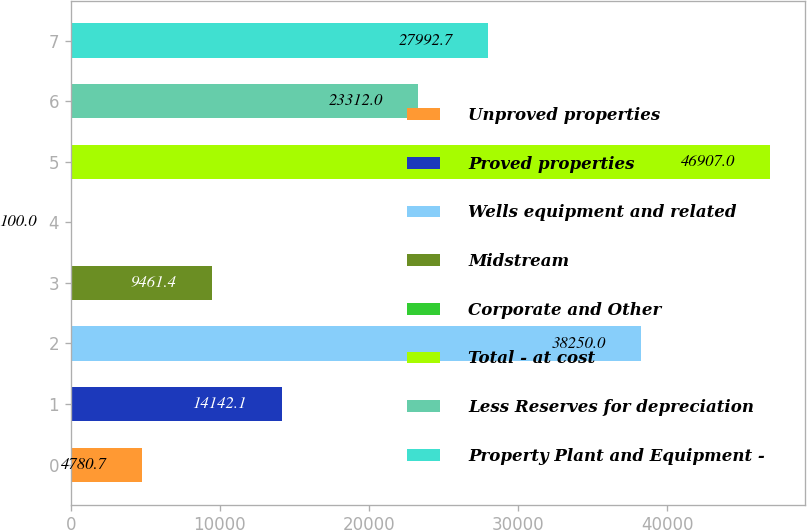Convert chart. <chart><loc_0><loc_0><loc_500><loc_500><bar_chart><fcel>Unproved properties<fcel>Proved properties<fcel>Wells equipment and related<fcel>Midstream<fcel>Corporate and Other<fcel>Total - at cost<fcel>Less Reserves for depreciation<fcel>Property Plant and Equipment -<nl><fcel>4780.7<fcel>14142.1<fcel>38250<fcel>9461.4<fcel>100<fcel>46907<fcel>23312<fcel>27992.7<nl></chart> 